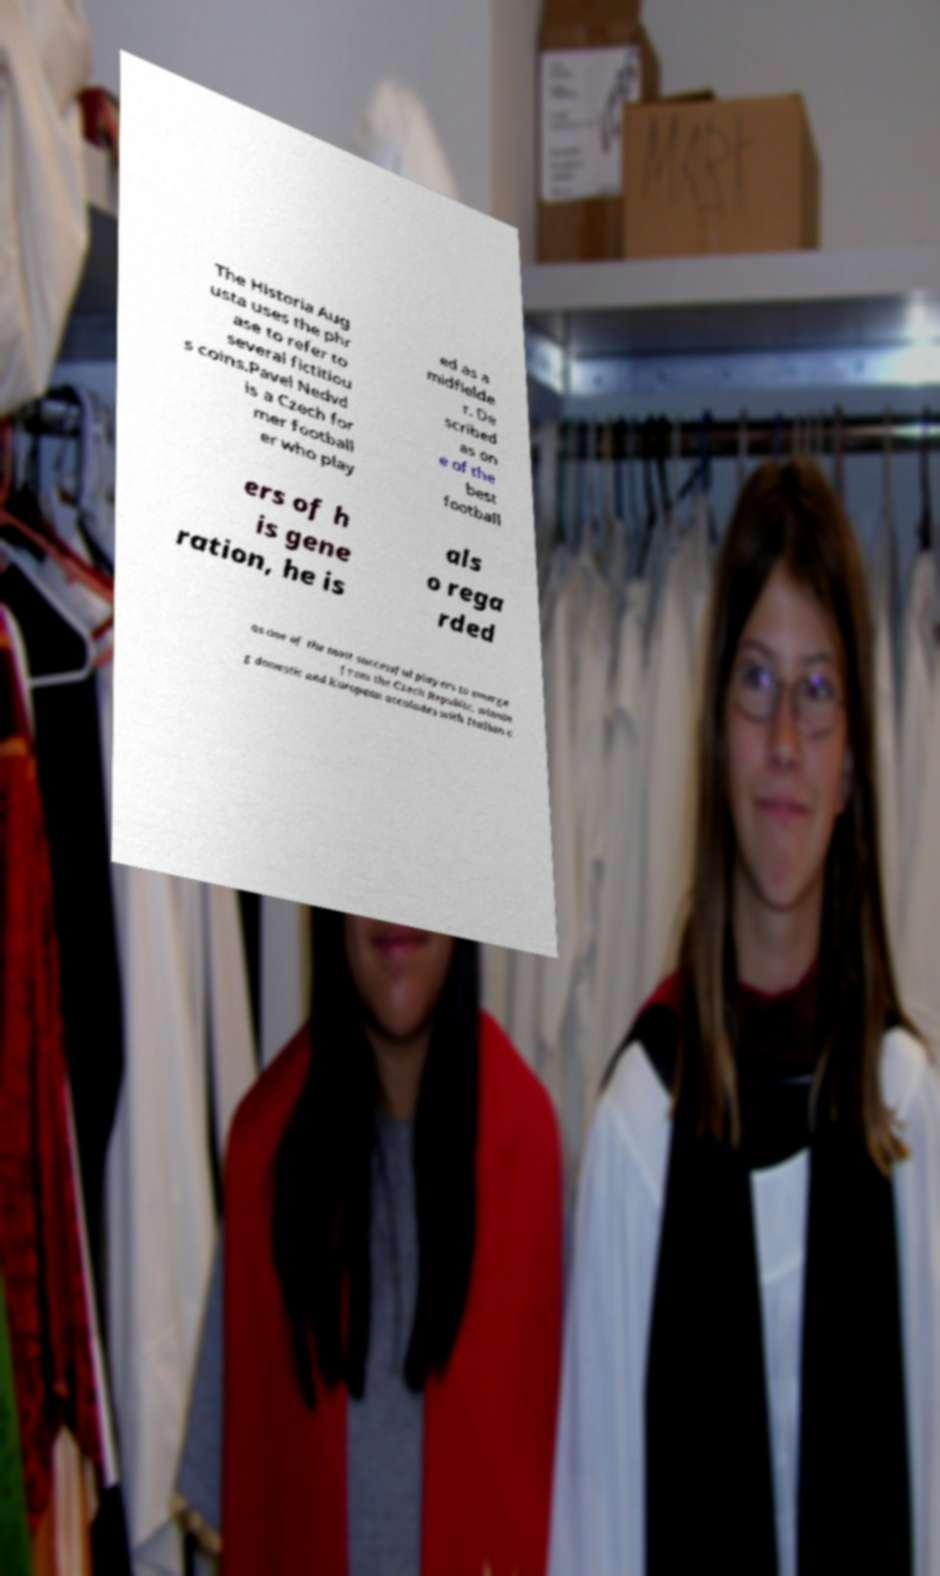Could you assist in decoding the text presented in this image and type it out clearly? The Historia Aug usta uses the phr ase to refer to several fictitiou s coins.Pavel Nedvd is a Czech for mer football er who play ed as a midfielde r. De scribed as on e of the best football ers of h is gene ration, he is als o rega rded as one of the most successful players to emerge from the Czech Republic, winnin g domestic and European accolades with Italian c 